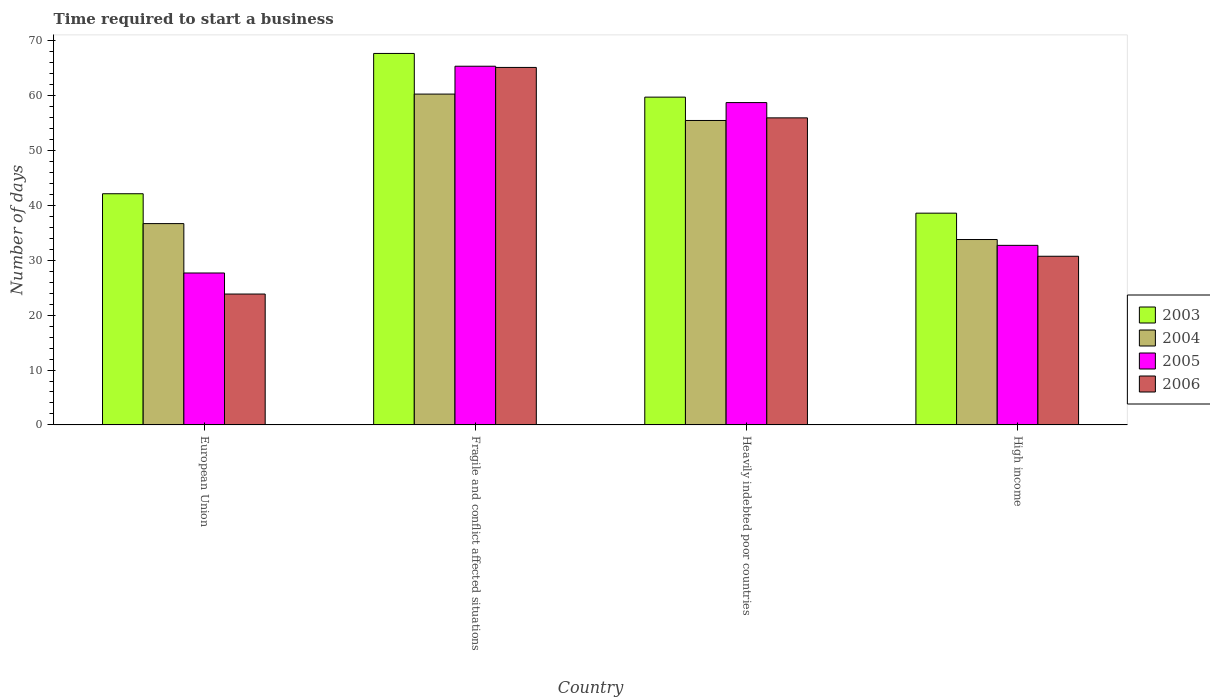How many different coloured bars are there?
Provide a short and direct response. 4. Are the number of bars on each tick of the X-axis equal?
Keep it short and to the point. Yes. How many bars are there on the 1st tick from the left?
Your answer should be compact. 4. What is the label of the 3rd group of bars from the left?
Give a very brief answer. Heavily indebted poor countries. What is the number of days required to start a business in 2004 in High income?
Your answer should be compact. 33.78. Across all countries, what is the maximum number of days required to start a business in 2004?
Your answer should be compact. 60.28. Across all countries, what is the minimum number of days required to start a business in 2005?
Provide a short and direct response. 27.68. In which country was the number of days required to start a business in 2004 maximum?
Keep it short and to the point. Fragile and conflict affected situations. What is the total number of days required to start a business in 2006 in the graph?
Provide a short and direct response. 175.66. What is the difference between the number of days required to start a business in 2003 in European Union and that in High income?
Offer a very short reply. 3.54. What is the difference between the number of days required to start a business in 2004 in Fragile and conflict affected situations and the number of days required to start a business in 2005 in Heavily indebted poor countries?
Provide a succinct answer. 1.55. What is the average number of days required to start a business in 2004 per country?
Your answer should be very brief. 46.55. What is the difference between the number of days required to start a business of/in 2004 and number of days required to start a business of/in 2006 in High income?
Your answer should be very brief. 3.05. In how many countries, is the number of days required to start a business in 2006 greater than 14 days?
Offer a terse response. 4. What is the ratio of the number of days required to start a business in 2004 in Fragile and conflict affected situations to that in Heavily indebted poor countries?
Provide a succinct answer. 1.09. What is the difference between the highest and the second highest number of days required to start a business in 2006?
Provide a short and direct response. 34.41. What is the difference between the highest and the lowest number of days required to start a business in 2005?
Your response must be concise. 37.68. Is the sum of the number of days required to start a business in 2006 in Heavily indebted poor countries and High income greater than the maximum number of days required to start a business in 2003 across all countries?
Your response must be concise. Yes. How many countries are there in the graph?
Offer a very short reply. 4. What is the difference between two consecutive major ticks on the Y-axis?
Provide a short and direct response. 10. Are the values on the major ticks of Y-axis written in scientific E-notation?
Offer a terse response. No. Where does the legend appear in the graph?
Your answer should be very brief. Center right. How many legend labels are there?
Your answer should be very brief. 4. How are the legend labels stacked?
Give a very brief answer. Vertical. What is the title of the graph?
Provide a short and direct response. Time required to start a business. Does "1963" appear as one of the legend labels in the graph?
Provide a short and direct response. No. What is the label or title of the X-axis?
Provide a short and direct response. Country. What is the label or title of the Y-axis?
Your response must be concise. Number of days. What is the Number of days of 2003 in European Union?
Your answer should be very brief. 42.12. What is the Number of days of 2004 in European Union?
Keep it short and to the point. 36.68. What is the Number of days in 2005 in European Union?
Make the answer very short. 27.68. What is the Number of days in 2006 in European Union?
Offer a terse response. 23.85. What is the Number of days of 2003 in Fragile and conflict affected situations?
Keep it short and to the point. 67.68. What is the Number of days of 2004 in Fragile and conflict affected situations?
Offer a terse response. 60.28. What is the Number of days in 2005 in Fragile and conflict affected situations?
Offer a terse response. 65.36. What is the Number of days in 2006 in Fragile and conflict affected situations?
Offer a very short reply. 65.14. What is the Number of days of 2003 in Heavily indebted poor countries?
Your answer should be compact. 59.72. What is the Number of days of 2004 in Heavily indebted poor countries?
Provide a succinct answer. 55.47. What is the Number of days in 2005 in Heavily indebted poor countries?
Give a very brief answer. 58.73. What is the Number of days in 2006 in Heavily indebted poor countries?
Give a very brief answer. 55.95. What is the Number of days in 2003 in High income?
Offer a very short reply. 38.58. What is the Number of days of 2004 in High income?
Offer a terse response. 33.78. What is the Number of days in 2005 in High income?
Offer a terse response. 32.72. What is the Number of days of 2006 in High income?
Ensure brevity in your answer.  30.73. Across all countries, what is the maximum Number of days in 2003?
Your response must be concise. 67.68. Across all countries, what is the maximum Number of days in 2004?
Offer a very short reply. 60.28. Across all countries, what is the maximum Number of days of 2005?
Offer a very short reply. 65.36. Across all countries, what is the maximum Number of days in 2006?
Offer a terse response. 65.14. Across all countries, what is the minimum Number of days of 2003?
Offer a very short reply. 38.58. Across all countries, what is the minimum Number of days of 2004?
Offer a very short reply. 33.78. Across all countries, what is the minimum Number of days of 2005?
Your answer should be very brief. 27.68. Across all countries, what is the minimum Number of days of 2006?
Provide a succinct answer. 23.85. What is the total Number of days of 2003 in the graph?
Make the answer very short. 208.11. What is the total Number of days of 2004 in the graph?
Give a very brief answer. 186.21. What is the total Number of days in 2005 in the graph?
Keep it short and to the point. 184.49. What is the total Number of days in 2006 in the graph?
Offer a terse response. 175.66. What is the difference between the Number of days of 2003 in European Union and that in Fragile and conflict affected situations?
Your answer should be very brief. -25.56. What is the difference between the Number of days of 2004 in European Union and that in Fragile and conflict affected situations?
Keep it short and to the point. -23.6. What is the difference between the Number of days of 2005 in European Union and that in Fragile and conflict affected situations?
Offer a terse response. -37.68. What is the difference between the Number of days of 2006 in European Union and that in Fragile and conflict affected situations?
Give a very brief answer. -41.29. What is the difference between the Number of days in 2003 in European Union and that in Heavily indebted poor countries?
Your response must be concise. -17.6. What is the difference between the Number of days of 2004 in European Union and that in Heavily indebted poor countries?
Ensure brevity in your answer.  -18.79. What is the difference between the Number of days of 2005 in European Union and that in Heavily indebted poor countries?
Provide a succinct answer. -31.05. What is the difference between the Number of days of 2006 in European Union and that in Heavily indebted poor countries?
Offer a very short reply. -32.1. What is the difference between the Number of days in 2003 in European Union and that in High income?
Provide a succinct answer. 3.54. What is the difference between the Number of days of 2004 in European Union and that in High income?
Provide a short and direct response. 2.9. What is the difference between the Number of days of 2005 in European Union and that in High income?
Your response must be concise. -5.04. What is the difference between the Number of days in 2006 in European Union and that in High income?
Give a very brief answer. -6.88. What is the difference between the Number of days in 2003 in Fragile and conflict affected situations and that in Heavily indebted poor countries?
Keep it short and to the point. 7.96. What is the difference between the Number of days of 2004 in Fragile and conflict affected situations and that in Heavily indebted poor countries?
Provide a succinct answer. 4.81. What is the difference between the Number of days in 2005 in Fragile and conflict affected situations and that in Heavily indebted poor countries?
Ensure brevity in your answer.  6.63. What is the difference between the Number of days in 2006 in Fragile and conflict affected situations and that in Heavily indebted poor countries?
Offer a terse response. 9.19. What is the difference between the Number of days of 2003 in Fragile and conflict affected situations and that in High income?
Give a very brief answer. 29.1. What is the difference between the Number of days of 2004 in Fragile and conflict affected situations and that in High income?
Keep it short and to the point. 26.5. What is the difference between the Number of days of 2005 in Fragile and conflict affected situations and that in High income?
Provide a short and direct response. 32.64. What is the difference between the Number of days in 2006 in Fragile and conflict affected situations and that in High income?
Offer a very short reply. 34.41. What is the difference between the Number of days in 2003 in Heavily indebted poor countries and that in High income?
Keep it short and to the point. 21.14. What is the difference between the Number of days in 2004 in Heavily indebted poor countries and that in High income?
Make the answer very short. 21.69. What is the difference between the Number of days of 2005 in Heavily indebted poor countries and that in High income?
Give a very brief answer. 26.01. What is the difference between the Number of days in 2006 in Heavily indebted poor countries and that in High income?
Give a very brief answer. 25.22. What is the difference between the Number of days in 2003 in European Union and the Number of days in 2004 in Fragile and conflict affected situations?
Provide a short and direct response. -18.16. What is the difference between the Number of days in 2003 in European Union and the Number of days in 2005 in Fragile and conflict affected situations?
Provide a short and direct response. -23.24. What is the difference between the Number of days in 2003 in European Union and the Number of days in 2006 in Fragile and conflict affected situations?
Ensure brevity in your answer.  -23.02. What is the difference between the Number of days of 2004 in European Union and the Number of days of 2005 in Fragile and conflict affected situations?
Provide a succinct answer. -28.68. What is the difference between the Number of days of 2004 in European Union and the Number of days of 2006 in Fragile and conflict affected situations?
Make the answer very short. -28.46. What is the difference between the Number of days of 2005 in European Union and the Number of days of 2006 in Fragile and conflict affected situations?
Offer a terse response. -37.46. What is the difference between the Number of days in 2003 in European Union and the Number of days in 2004 in Heavily indebted poor countries?
Keep it short and to the point. -13.35. What is the difference between the Number of days in 2003 in European Union and the Number of days in 2005 in Heavily indebted poor countries?
Make the answer very short. -16.61. What is the difference between the Number of days of 2003 in European Union and the Number of days of 2006 in Heavily indebted poor countries?
Your response must be concise. -13.83. What is the difference between the Number of days in 2004 in European Union and the Number of days in 2005 in Heavily indebted poor countries?
Your response must be concise. -22.05. What is the difference between the Number of days of 2004 in European Union and the Number of days of 2006 in Heavily indebted poor countries?
Give a very brief answer. -19.27. What is the difference between the Number of days in 2005 in European Union and the Number of days in 2006 in Heavily indebted poor countries?
Ensure brevity in your answer.  -28.27. What is the difference between the Number of days in 2003 in European Union and the Number of days in 2004 in High income?
Ensure brevity in your answer.  8.34. What is the difference between the Number of days of 2003 in European Union and the Number of days of 2005 in High income?
Keep it short and to the point. 9.4. What is the difference between the Number of days in 2003 in European Union and the Number of days in 2006 in High income?
Offer a very short reply. 11.39. What is the difference between the Number of days in 2004 in European Union and the Number of days in 2005 in High income?
Ensure brevity in your answer.  3.96. What is the difference between the Number of days in 2004 in European Union and the Number of days in 2006 in High income?
Make the answer very short. 5.95. What is the difference between the Number of days in 2005 in European Union and the Number of days in 2006 in High income?
Your answer should be very brief. -3.05. What is the difference between the Number of days of 2003 in Fragile and conflict affected situations and the Number of days of 2004 in Heavily indebted poor countries?
Keep it short and to the point. 12.21. What is the difference between the Number of days of 2003 in Fragile and conflict affected situations and the Number of days of 2005 in Heavily indebted poor countries?
Your answer should be compact. 8.95. What is the difference between the Number of days of 2003 in Fragile and conflict affected situations and the Number of days of 2006 in Heavily indebted poor countries?
Your answer should be very brief. 11.74. What is the difference between the Number of days of 2004 in Fragile and conflict affected situations and the Number of days of 2005 in Heavily indebted poor countries?
Offer a terse response. 1.55. What is the difference between the Number of days in 2004 in Fragile and conflict affected situations and the Number of days in 2006 in Heavily indebted poor countries?
Your answer should be very brief. 4.33. What is the difference between the Number of days of 2005 in Fragile and conflict affected situations and the Number of days of 2006 in Heavily indebted poor countries?
Offer a terse response. 9.41. What is the difference between the Number of days of 2003 in Fragile and conflict affected situations and the Number of days of 2004 in High income?
Provide a short and direct response. 33.91. What is the difference between the Number of days of 2003 in Fragile and conflict affected situations and the Number of days of 2005 in High income?
Make the answer very short. 34.97. What is the difference between the Number of days of 2003 in Fragile and conflict affected situations and the Number of days of 2006 in High income?
Offer a very short reply. 36.95. What is the difference between the Number of days of 2004 in Fragile and conflict affected situations and the Number of days of 2005 in High income?
Keep it short and to the point. 27.56. What is the difference between the Number of days of 2004 in Fragile and conflict affected situations and the Number of days of 2006 in High income?
Provide a short and direct response. 29.55. What is the difference between the Number of days of 2005 in Fragile and conflict affected situations and the Number of days of 2006 in High income?
Provide a short and direct response. 34.63. What is the difference between the Number of days of 2003 in Heavily indebted poor countries and the Number of days of 2004 in High income?
Offer a terse response. 25.95. What is the difference between the Number of days in 2003 in Heavily indebted poor countries and the Number of days in 2005 in High income?
Provide a short and direct response. 27.01. What is the difference between the Number of days in 2003 in Heavily indebted poor countries and the Number of days in 2006 in High income?
Your answer should be compact. 28.99. What is the difference between the Number of days in 2004 in Heavily indebted poor countries and the Number of days in 2005 in High income?
Your answer should be very brief. 22.75. What is the difference between the Number of days in 2004 in Heavily indebted poor countries and the Number of days in 2006 in High income?
Your answer should be compact. 24.74. What is the difference between the Number of days of 2005 in Heavily indebted poor countries and the Number of days of 2006 in High income?
Offer a terse response. 28. What is the average Number of days of 2003 per country?
Give a very brief answer. 52.03. What is the average Number of days of 2004 per country?
Provide a short and direct response. 46.55. What is the average Number of days in 2005 per country?
Make the answer very short. 46.12. What is the average Number of days of 2006 per country?
Make the answer very short. 43.92. What is the difference between the Number of days of 2003 and Number of days of 2004 in European Union?
Keep it short and to the point. 5.44. What is the difference between the Number of days in 2003 and Number of days in 2005 in European Union?
Provide a short and direct response. 14.44. What is the difference between the Number of days in 2003 and Number of days in 2006 in European Union?
Ensure brevity in your answer.  18.27. What is the difference between the Number of days in 2004 and Number of days in 2005 in European Union?
Provide a short and direct response. 9. What is the difference between the Number of days of 2004 and Number of days of 2006 in European Union?
Offer a terse response. 12.83. What is the difference between the Number of days in 2005 and Number of days in 2006 in European Union?
Make the answer very short. 3.83. What is the difference between the Number of days in 2003 and Number of days in 2004 in Fragile and conflict affected situations?
Keep it short and to the point. 7.4. What is the difference between the Number of days of 2003 and Number of days of 2005 in Fragile and conflict affected situations?
Provide a succinct answer. 2.33. What is the difference between the Number of days of 2003 and Number of days of 2006 in Fragile and conflict affected situations?
Your answer should be compact. 2.55. What is the difference between the Number of days of 2004 and Number of days of 2005 in Fragile and conflict affected situations?
Keep it short and to the point. -5.08. What is the difference between the Number of days in 2004 and Number of days in 2006 in Fragile and conflict affected situations?
Your answer should be compact. -4.86. What is the difference between the Number of days of 2005 and Number of days of 2006 in Fragile and conflict affected situations?
Provide a succinct answer. 0.22. What is the difference between the Number of days in 2003 and Number of days in 2004 in Heavily indebted poor countries?
Make the answer very short. 4.25. What is the difference between the Number of days of 2003 and Number of days of 2005 in Heavily indebted poor countries?
Your answer should be very brief. 0.99. What is the difference between the Number of days of 2003 and Number of days of 2006 in Heavily indebted poor countries?
Your response must be concise. 3.78. What is the difference between the Number of days of 2004 and Number of days of 2005 in Heavily indebted poor countries?
Offer a terse response. -3.26. What is the difference between the Number of days of 2004 and Number of days of 2006 in Heavily indebted poor countries?
Offer a very short reply. -0.48. What is the difference between the Number of days in 2005 and Number of days in 2006 in Heavily indebted poor countries?
Offer a terse response. 2.78. What is the difference between the Number of days in 2003 and Number of days in 2004 in High income?
Provide a short and direct response. 4.8. What is the difference between the Number of days of 2003 and Number of days of 2005 in High income?
Offer a very short reply. 5.86. What is the difference between the Number of days in 2003 and Number of days in 2006 in High income?
Offer a terse response. 7.85. What is the difference between the Number of days of 2004 and Number of days of 2005 in High income?
Keep it short and to the point. 1.06. What is the difference between the Number of days of 2004 and Number of days of 2006 in High income?
Your answer should be very brief. 3.05. What is the difference between the Number of days in 2005 and Number of days in 2006 in High income?
Offer a terse response. 1.99. What is the ratio of the Number of days of 2003 in European Union to that in Fragile and conflict affected situations?
Offer a terse response. 0.62. What is the ratio of the Number of days in 2004 in European Union to that in Fragile and conflict affected situations?
Provide a succinct answer. 0.61. What is the ratio of the Number of days of 2005 in European Union to that in Fragile and conflict affected situations?
Offer a terse response. 0.42. What is the ratio of the Number of days of 2006 in European Union to that in Fragile and conflict affected situations?
Your answer should be very brief. 0.37. What is the ratio of the Number of days in 2003 in European Union to that in Heavily indebted poor countries?
Provide a succinct answer. 0.71. What is the ratio of the Number of days in 2004 in European Union to that in Heavily indebted poor countries?
Provide a short and direct response. 0.66. What is the ratio of the Number of days of 2005 in European Union to that in Heavily indebted poor countries?
Your response must be concise. 0.47. What is the ratio of the Number of days of 2006 in European Union to that in Heavily indebted poor countries?
Keep it short and to the point. 0.43. What is the ratio of the Number of days of 2003 in European Union to that in High income?
Give a very brief answer. 1.09. What is the ratio of the Number of days of 2004 in European Union to that in High income?
Keep it short and to the point. 1.09. What is the ratio of the Number of days of 2005 in European Union to that in High income?
Keep it short and to the point. 0.85. What is the ratio of the Number of days of 2006 in European Union to that in High income?
Your answer should be very brief. 0.78. What is the ratio of the Number of days of 2003 in Fragile and conflict affected situations to that in Heavily indebted poor countries?
Make the answer very short. 1.13. What is the ratio of the Number of days in 2004 in Fragile and conflict affected situations to that in Heavily indebted poor countries?
Offer a terse response. 1.09. What is the ratio of the Number of days in 2005 in Fragile and conflict affected situations to that in Heavily indebted poor countries?
Your answer should be very brief. 1.11. What is the ratio of the Number of days of 2006 in Fragile and conflict affected situations to that in Heavily indebted poor countries?
Your response must be concise. 1.16. What is the ratio of the Number of days of 2003 in Fragile and conflict affected situations to that in High income?
Offer a terse response. 1.75. What is the ratio of the Number of days of 2004 in Fragile and conflict affected situations to that in High income?
Your answer should be very brief. 1.78. What is the ratio of the Number of days of 2005 in Fragile and conflict affected situations to that in High income?
Give a very brief answer. 2. What is the ratio of the Number of days in 2006 in Fragile and conflict affected situations to that in High income?
Offer a very short reply. 2.12. What is the ratio of the Number of days of 2003 in Heavily indebted poor countries to that in High income?
Ensure brevity in your answer.  1.55. What is the ratio of the Number of days of 2004 in Heavily indebted poor countries to that in High income?
Ensure brevity in your answer.  1.64. What is the ratio of the Number of days of 2005 in Heavily indebted poor countries to that in High income?
Provide a short and direct response. 1.79. What is the ratio of the Number of days of 2006 in Heavily indebted poor countries to that in High income?
Offer a very short reply. 1.82. What is the difference between the highest and the second highest Number of days in 2003?
Your answer should be very brief. 7.96. What is the difference between the highest and the second highest Number of days in 2004?
Provide a short and direct response. 4.81. What is the difference between the highest and the second highest Number of days in 2005?
Your answer should be very brief. 6.63. What is the difference between the highest and the second highest Number of days of 2006?
Keep it short and to the point. 9.19. What is the difference between the highest and the lowest Number of days in 2003?
Your response must be concise. 29.1. What is the difference between the highest and the lowest Number of days in 2004?
Provide a short and direct response. 26.5. What is the difference between the highest and the lowest Number of days in 2005?
Provide a short and direct response. 37.68. What is the difference between the highest and the lowest Number of days of 2006?
Provide a succinct answer. 41.29. 